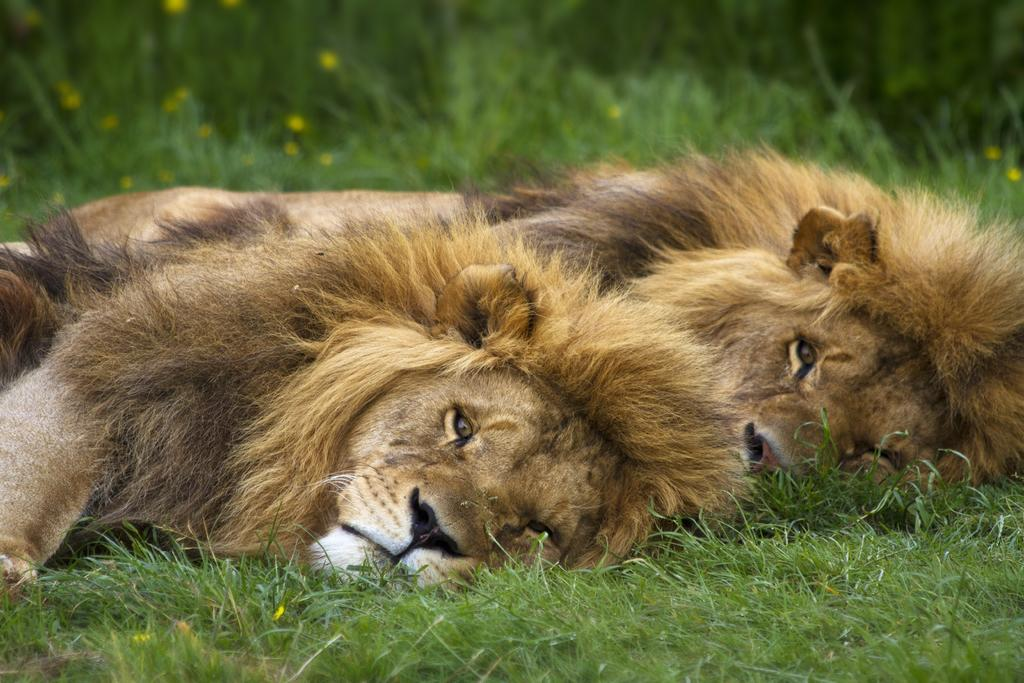What animals can be seen in the image? There are two lions in the image. What are the lions doing in the image? The lions are resting on the ground. What type of surface are the lions resting on? The ground is covered with grass. Can you describe the background of the image? The background of the image is blurred. What type of jewel can be seen on the lion's head in the image? There are no jewels present on the lions' heads in the image. Can you tell me how much water is coming out of the faucet in the image? There is no faucet present in the image. 